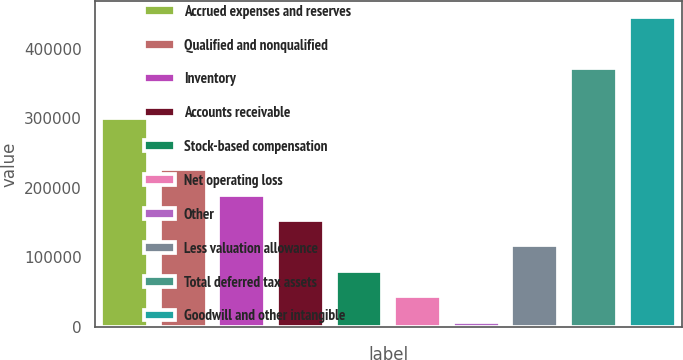Convert chart to OTSL. <chart><loc_0><loc_0><loc_500><loc_500><bar_chart><fcel>Accrued expenses and reserves<fcel>Qualified and nonqualified<fcel>Inventory<fcel>Accounts receivable<fcel>Stock-based compensation<fcel>Net operating loss<fcel>Other<fcel>Less valuation allowance<fcel>Total deferred tax assets<fcel>Goodwill and other intangible<nl><fcel>300058<fcel>226968<fcel>190424<fcel>153879<fcel>80788.8<fcel>44243.9<fcel>7699<fcel>117334<fcel>373148<fcel>446238<nl></chart> 